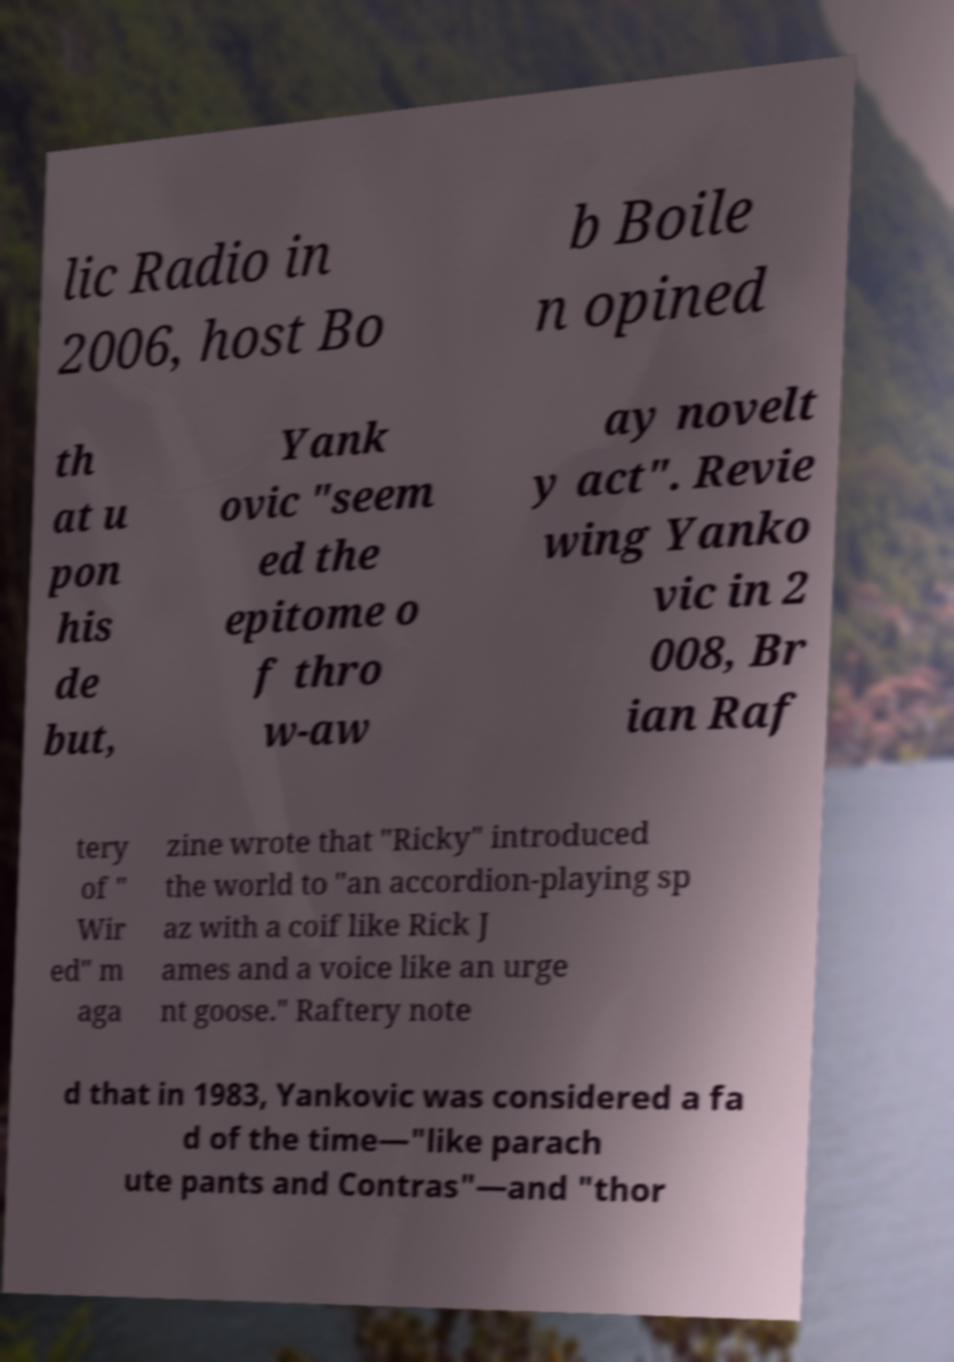I need the written content from this picture converted into text. Can you do that? lic Radio in 2006, host Bo b Boile n opined th at u pon his de but, Yank ovic "seem ed the epitome o f thro w-aw ay novelt y act". Revie wing Yanko vic in 2 008, Br ian Raf tery of " Wir ed" m aga zine wrote that "Ricky" introduced the world to "an accordion-playing sp az with a coif like Rick J ames and a voice like an urge nt goose." Raftery note d that in 1983, Yankovic was considered a fa d of the time—"like parach ute pants and Contras"—and "thor 